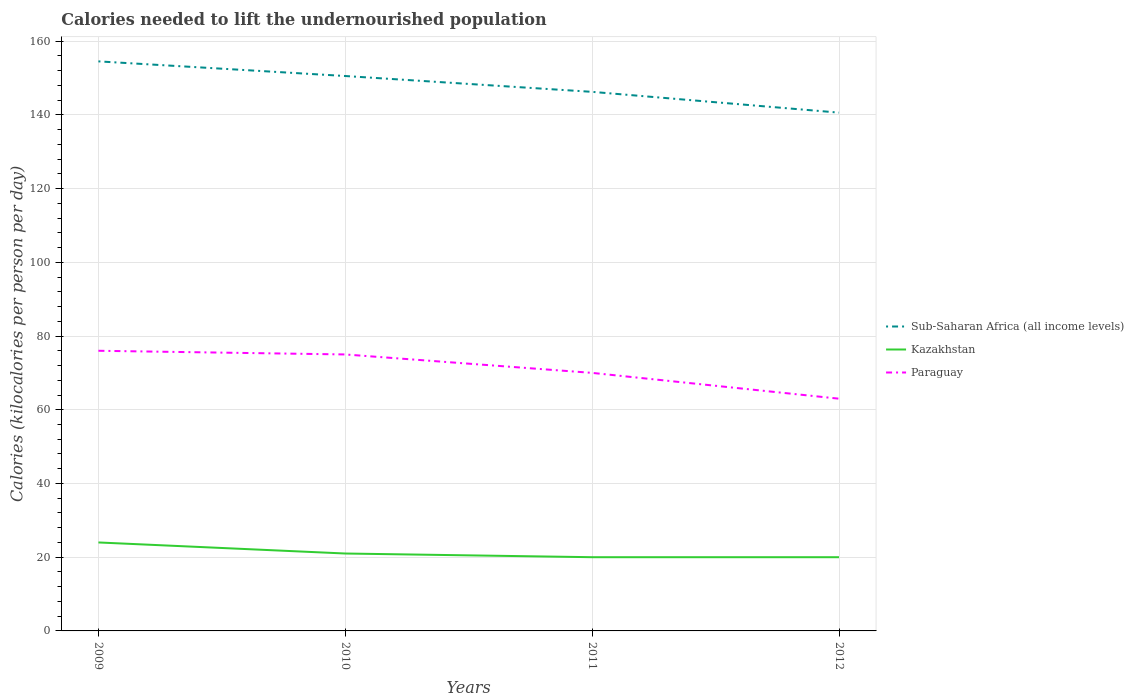How many different coloured lines are there?
Keep it short and to the point. 3. Across all years, what is the maximum total calories needed to lift the undernourished population in Paraguay?
Provide a succinct answer. 63. In which year was the total calories needed to lift the undernourished population in Sub-Saharan Africa (all income levels) maximum?
Ensure brevity in your answer.  2012. What is the total total calories needed to lift the undernourished population in Sub-Saharan Africa (all income levels) in the graph?
Your response must be concise. 4.3. What is the difference between the highest and the second highest total calories needed to lift the undernourished population in Paraguay?
Your answer should be compact. 13. What is the difference between the highest and the lowest total calories needed to lift the undernourished population in Sub-Saharan Africa (all income levels)?
Your response must be concise. 2. How many lines are there?
Your answer should be compact. 3. Are the values on the major ticks of Y-axis written in scientific E-notation?
Give a very brief answer. No. Where does the legend appear in the graph?
Your answer should be very brief. Center right. How many legend labels are there?
Provide a short and direct response. 3. What is the title of the graph?
Your response must be concise. Calories needed to lift the undernourished population. What is the label or title of the X-axis?
Keep it short and to the point. Years. What is the label or title of the Y-axis?
Offer a very short reply. Calories (kilocalories per person per day). What is the Calories (kilocalories per person per day) in Sub-Saharan Africa (all income levels) in 2009?
Make the answer very short. 154.51. What is the Calories (kilocalories per person per day) in Kazakhstan in 2009?
Give a very brief answer. 24. What is the Calories (kilocalories per person per day) of Paraguay in 2009?
Your answer should be compact. 76. What is the Calories (kilocalories per person per day) in Sub-Saharan Africa (all income levels) in 2010?
Keep it short and to the point. 150.54. What is the Calories (kilocalories per person per day) in Kazakhstan in 2010?
Ensure brevity in your answer.  21. What is the Calories (kilocalories per person per day) in Paraguay in 2010?
Offer a terse response. 75. What is the Calories (kilocalories per person per day) of Sub-Saharan Africa (all income levels) in 2011?
Provide a short and direct response. 146.24. What is the Calories (kilocalories per person per day) of Paraguay in 2011?
Offer a terse response. 70. What is the Calories (kilocalories per person per day) in Sub-Saharan Africa (all income levels) in 2012?
Your answer should be very brief. 140.6. What is the Calories (kilocalories per person per day) of Kazakhstan in 2012?
Provide a short and direct response. 20. What is the Calories (kilocalories per person per day) in Paraguay in 2012?
Keep it short and to the point. 63. Across all years, what is the maximum Calories (kilocalories per person per day) in Sub-Saharan Africa (all income levels)?
Offer a very short reply. 154.51. Across all years, what is the maximum Calories (kilocalories per person per day) in Kazakhstan?
Provide a short and direct response. 24. Across all years, what is the maximum Calories (kilocalories per person per day) of Paraguay?
Make the answer very short. 76. Across all years, what is the minimum Calories (kilocalories per person per day) in Sub-Saharan Africa (all income levels)?
Provide a succinct answer. 140.6. Across all years, what is the minimum Calories (kilocalories per person per day) in Paraguay?
Provide a succinct answer. 63. What is the total Calories (kilocalories per person per day) of Sub-Saharan Africa (all income levels) in the graph?
Ensure brevity in your answer.  591.89. What is the total Calories (kilocalories per person per day) in Paraguay in the graph?
Your answer should be very brief. 284. What is the difference between the Calories (kilocalories per person per day) in Sub-Saharan Africa (all income levels) in 2009 and that in 2010?
Offer a very short reply. 3.97. What is the difference between the Calories (kilocalories per person per day) of Sub-Saharan Africa (all income levels) in 2009 and that in 2011?
Offer a very short reply. 8.27. What is the difference between the Calories (kilocalories per person per day) of Paraguay in 2009 and that in 2011?
Offer a very short reply. 6. What is the difference between the Calories (kilocalories per person per day) in Sub-Saharan Africa (all income levels) in 2009 and that in 2012?
Offer a terse response. 13.91. What is the difference between the Calories (kilocalories per person per day) of Sub-Saharan Africa (all income levels) in 2010 and that in 2011?
Keep it short and to the point. 4.3. What is the difference between the Calories (kilocalories per person per day) in Kazakhstan in 2010 and that in 2011?
Your answer should be very brief. 1. What is the difference between the Calories (kilocalories per person per day) in Sub-Saharan Africa (all income levels) in 2010 and that in 2012?
Offer a very short reply. 9.93. What is the difference between the Calories (kilocalories per person per day) of Kazakhstan in 2010 and that in 2012?
Offer a very short reply. 1. What is the difference between the Calories (kilocalories per person per day) of Paraguay in 2010 and that in 2012?
Provide a short and direct response. 12. What is the difference between the Calories (kilocalories per person per day) in Sub-Saharan Africa (all income levels) in 2011 and that in 2012?
Make the answer very short. 5.64. What is the difference between the Calories (kilocalories per person per day) of Kazakhstan in 2011 and that in 2012?
Your answer should be very brief. 0. What is the difference between the Calories (kilocalories per person per day) of Paraguay in 2011 and that in 2012?
Offer a very short reply. 7. What is the difference between the Calories (kilocalories per person per day) in Sub-Saharan Africa (all income levels) in 2009 and the Calories (kilocalories per person per day) in Kazakhstan in 2010?
Offer a terse response. 133.51. What is the difference between the Calories (kilocalories per person per day) in Sub-Saharan Africa (all income levels) in 2009 and the Calories (kilocalories per person per day) in Paraguay in 2010?
Give a very brief answer. 79.51. What is the difference between the Calories (kilocalories per person per day) of Kazakhstan in 2009 and the Calories (kilocalories per person per day) of Paraguay in 2010?
Provide a succinct answer. -51. What is the difference between the Calories (kilocalories per person per day) in Sub-Saharan Africa (all income levels) in 2009 and the Calories (kilocalories per person per day) in Kazakhstan in 2011?
Offer a very short reply. 134.51. What is the difference between the Calories (kilocalories per person per day) of Sub-Saharan Africa (all income levels) in 2009 and the Calories (kilocalories per person per day) of Paraguay in 2011?
Keep it short and to the point. 84.51. What is the difference between the Calories (kilocalories per person per day) in Kazakhstan in 2009 and the Calories (kilocalories per person per day) in Paraguay in 2011?
Offer a terse response. -46. What is the difference between the Calories (kilocalories per person per day) in Sub-Saharan Africa (all income levels) in 2009 and the Calories (kilocalories per person per day) in Kazakhstan in 2012?
Offer a very short reply. 134.51. What is the difference between the Calories (kilocalories per person per day) in Sub-Saharan Africa (all income levels) in 2009 and the Calories (kilocalories per person per day) in Paraguay in 2012?
Your answer should be very brief. 91.51. What is the difference between the Calories (kilocalories per person per day) of Kazakhstan in 2009 and the Calories (kilocalories per person per day) of Paraguay in 2012?
Your response must be concise. -39. What is the difference between the Calories (kilocalories per person per day) in Sub-Saharan Africa (all income levels) in 2010 and the Calories (kilocalories per person per day) in Kazakhstan in 2011?
Ensure brevity in your answer.  130.54. What is the difference between the Calories (kilocalories per person per day) in Sub-Saharan Africa (all income levels) in 2010 and the Calories (kilocalories per person per day) in Paraguay in 2011?
Make the answer very short. 80.54. What is the difference between the Calories (kilocalories per person per day) of Kazakhstan in 2010 and the Calories (kilocalories per person per day) of Paraguay in 2011?
Offer a very short reply. -49. What is the difference between the Calories (kilocalories per person per day) in Sub-Saharan Africa (all income levels) in 2010 and the Calories (kilocalories per person per day) in Kazakhstan in 2012?
Make the answer very short. 130.54. What is the difference between the Calories (kilocalories per person per day) of Sub-Saharan Africa (all income levels) in 2010 and the Calories (kilocalories per person per day) of Paraguay in 2012?
Provide a succinct answer. 87.54. What is the difference between the Calories (kilocalories per person per day) in Kazakhstan in 2010 and the Calories (kilocalories per person per day) in Paraguay in 2012?
Make the answer very short. -42. What is the difference between the Calories (kilocalories per person per day) in Sub-Saharan Africa (all income levels) in 2011 and the Calories (kilocalories per person per day) in Kazakhstan in 2012?
Offer a terse response. 126.24. What is the difference between the Calories (kilocalories per person per day) of Sub-Saharan Africa (all income levels) in 2011 and the Calories (kilocalories per person per day) of Paraguay in 2012?
Provide a succinct answer. 83.24. What is the difference between the Calories (kilocalories per person per day) in Kazakhstan in 2011 and the Calories (kilocalories per person per day) in Paraguay in 2012?
Ensure brevity in your answer.  -43. What is the average Calories (kilocalories per person per day) in Sub-Saharan Africa (all income levels) per year?
Provide a short and direct response. 147.97. What is the average Calories (kilocalories per person per day) in Kazakhstan per year?
Ensure brevity in your answer.  21.25. In the year 2009, what is the difference between the Calories (kilocalories per person per day) in Sub-Saharan Africa (all income levels) and Calories (kilocalories per person per day) in Kazakhstan?
Keep it short and to the point. 130.51. In the year 2009, what is the difference between the Calories (kilocalories per person per day) of Sub-Saharan Africa (all income levels) and Calories (kilocalories per person per day) of Paraguay?
Your answer should be very brief. 78.51. In the year 2009, what is the difference between the Calories (kilocalories per person per day) of Kazakhstan and Calories (kilocalories per person per day) of Paraguay?
Keep it short and to the point. -52. In the year 2010, what is the difference between the Calories (kilocalories per person per day) of Sub-Saharan Africa (all income levels) and Calories (kilocalories per person per day) of Kazakhstan?
Keep it short and to the point. 129.54. In the year 2010, what is the difference between the Calories (kilocalories per person per day) in Sub-Saharan Africa (all income levels) and Calories (kilocalories per person per day) in Paraguay?
Your answer should be compact. 75.54. In the year 2010, what is the difference between the Calories (kilocalories per person per day) in Kazakhstan and Calories (kilocalories per person per day) in Paraguay?
Offer a very short reply. -54. In the year 2011, what is the difference between the Calories (kilocalories per person per day) in Sub-Saharan Africa (all income levels) and Calories (kilocalories per person per day) in Kazakhstan?
Keep it short and to the point. 126.24. In the year 2011, what is the difference between the Calories (kilocalories per person per day) in Sub-Saharan Africa (all income levels) and Calories (kilocalories per person per day) in Paraguay?
Make the answer very short. 76.24. In the year 2012, what is the difference between the Calories (kilocalories per person per day) in Sub-Saharan Africa (all income levels) and Calories (kilocalories per person per day) in Kazakhstan?
Your response must be concise. 120.6. In the year 2012, what is the difference between the Calories (kilocalories per person per day) in Sub-Saharan Africa (all income levels) and Calories (kilocalories per person per day) in Paraguay?
Ensure brevity in your answer.  77.6. In the year 2012, what is the difference between the Calories (kilocalories per person per day) of Kazakhstan and Calories (kilocalories per person per day) of Paraguay?
Your response must be concise. -43. What is the ratio of the Calories (kilocalories per person per day) of Sub-Saharan Africa (all income levels) in 2009 to that in 2010?
Keep it short and to the point. 1.03. What is the ratio of the Calories (kilocalories per person per day) of Kazakhstan in 2009 to that in 2010?
Your answer should be very brief. 1.14. What is the ratio of the Calories (kilocalories per person per day) in Paraguay in 2009 to that in 2010?
Your response must be concise. 1.01. What is the ratio of the Calories (kilocalories per person per day) in Sub-Saharan Africa (all income levels) in 2009 to that in 2011?
Offer a very short reply. 1.06. What is the ratio of the Calories (kilocalories per person per day) of Kazakhstan in 2009 to that in 2011?
Provide a short and direct response. 1.2. What is the ratio of the Calories (kilocalories per person per day) of Paraguay in 2009 to that in 2011?
Keep it short and to the point. 1.09. What is the ratio of the Calories (kilocalories per person per day) in Sub-Saharan Africa (all income levels) in 2009 to that in 2012?
Offer a terse response. 1.1. What is the ratio of the Calories (kilocalories per person per day) in Paraguay in 2009 to that in 2012?
Give a very brief answer. 1.21. What is the ratio of the Calories (kilocalories per person per day) in Sub-Saharan Africa (all income levels) in 2010 to that in 2011?
Provide a short and direct response. 1.03. What is the ratio of the Calories (kilocalories per person per day) in Kazakhstan in 2010 to that in 2011?
Your answer should be compact. 1.05. What is the ratio of the Calories (kilocalories per person per day) of Paraguay in 2010 to that in 2011?
Provide a succinct answer. 1.07. What is the ratio of the Calories (kilocalories per person per day) of Sub-Saharan Africa (all income levels) in 2010 to that in 2012?
Provide a short and direct response. 1.07. What is the ratio of the Calories (kilocalories per person per day) of Paraguay in 2010 to that in 2012?
Make the answer very short. 1.19. What is the ratio of the Calories (kilocalories per person per day) in Sub-Saharan Africa (all income levels) in 2011 to that in 2012?
Offer a terse response. 1.04. What is the ratio of the Calories (kilocalories per person per day) in Paraguay in 2011 to that in 2012?
Ensure brevity in your answer.  1.11. What is the difference between the highest and the second highest Calories (kilocalories per person per day) of Sub-Saharan Africa (all income levels)?
Your answer should be very brief. 3.97. What is the difference between the highest and the second highest Calories (kilocalories per person per day) of Paraguay?
Keep it short and to the point. 1. What is the difference between the highest and the lowest Calories (kilocalories per person per day) in Sub-Saharan Africa (all income levels)?
Give a very brief answer. 13.91. What is the difference between the highest and the lowest Calories (kilocalories per person per day) of Kazakhstan?
Your answer should be compact. 4. What is the difference between the highest and the lowest Calories (kilocalories per person per day) in Paraguay?
Give a very brief answer. 13. 